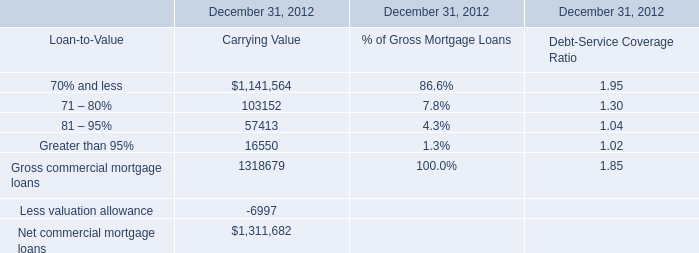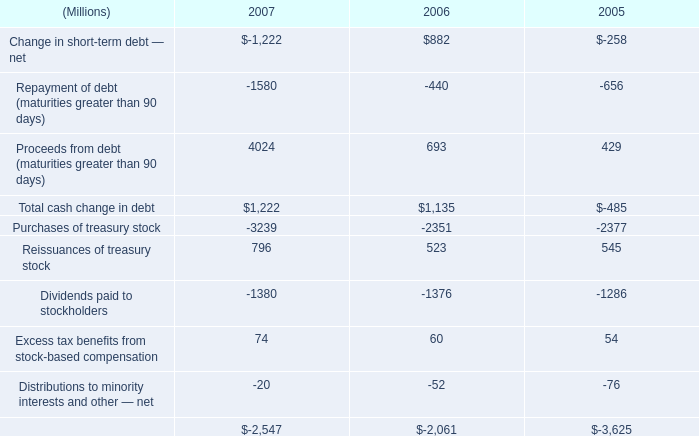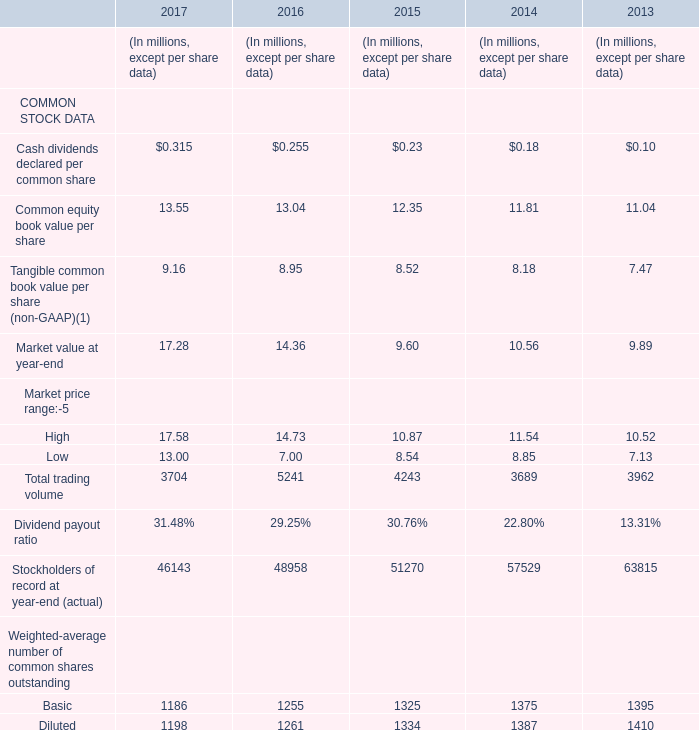What's the growth rate of Common equity book value per share in 2016? 
Computations: ((13.04 - 12.35) / 12.35)
Answer: 0.05587. 